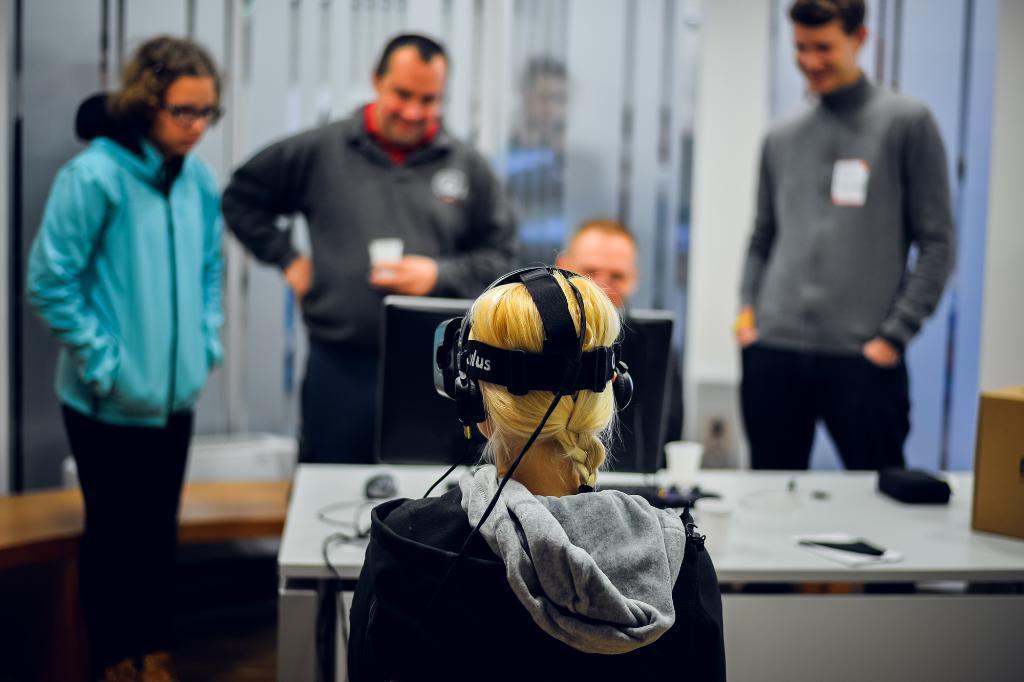Could you give a brief overview of what you see in this image? In the image we can see a woman sitting, wearing clothes, headsets and she is facing back. There are even other people standing, wearing clothes and it looks like they are smiling. Here we can see an electronic device, table, cable wires and the background is blurred. 